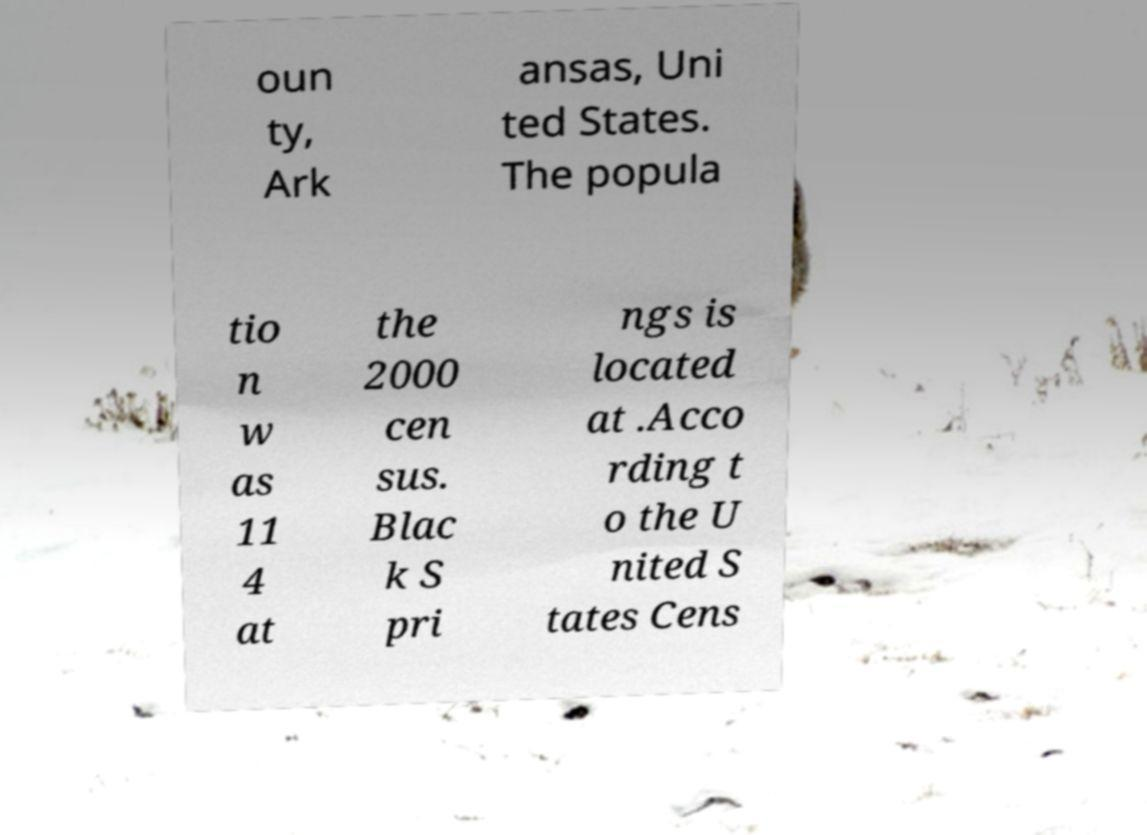Could you assist in decoding the text presented in this image and type it out clearly? oun ty, Ark ansas, Uni ted States. The popula tio n w as 11 4 at the 2000 cen sus. Blac k S pri ngs is located at .Acco rding t o the U nited S tates Cens 